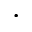Convert formula to latex. <formula><loc_0><loc_0><loc_500><loc_500>\cdot</formula> 